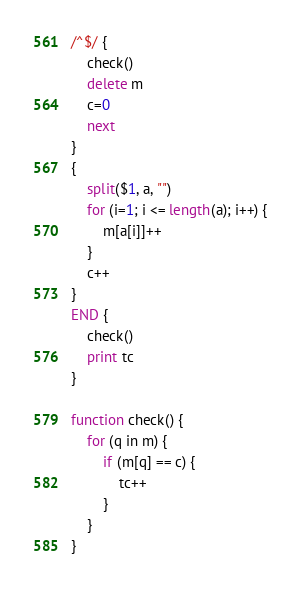Convert code to text. <code><loc_0><loc_0><loc_500><loc_500><_Awk_>/^$/ {
	check()
	delete m
	c=0
	next
}
{
	split($1, a, "")
	for (i=1; i <= length(a); i++) {
		m[a[i]]++
	}
	c++
}
END {
	check()
	print tc
}

function check() {
	for (q in m) {
		if (m[q] == c) {
			tc++
		}
	}
}</code> 